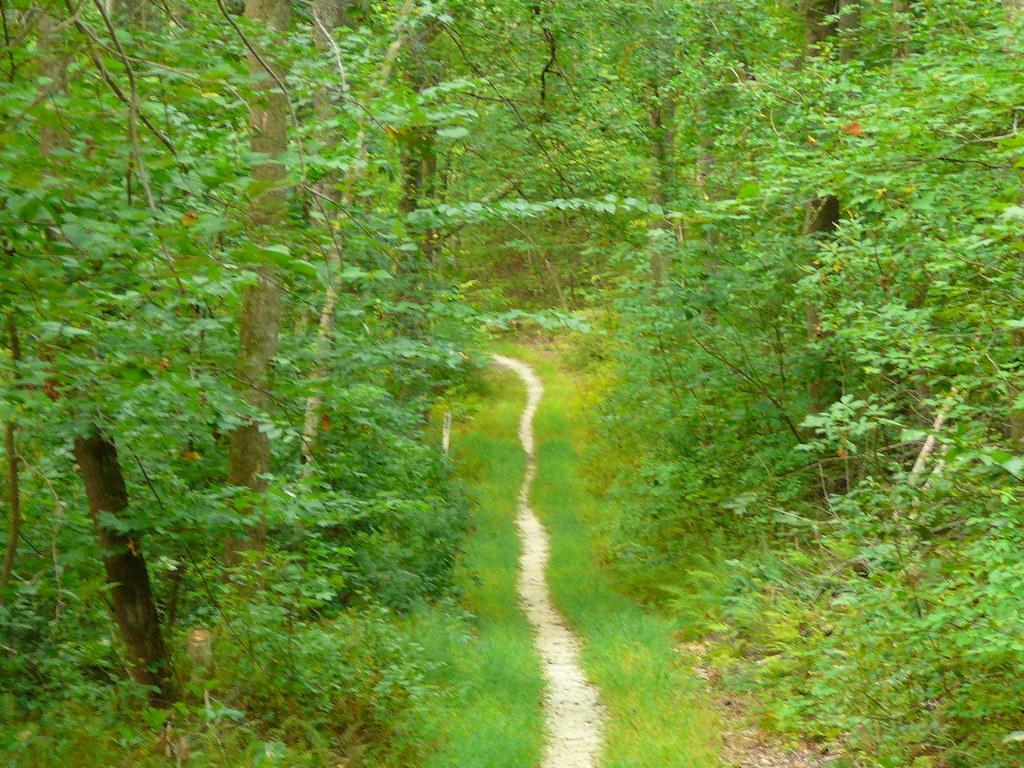Could you give a brief overview of what you see in this image? It seems to be a forest. At the bottom there is a path. On both sides of the path, I can see the grass. On the right and left side of the image there are many plants and trees. 